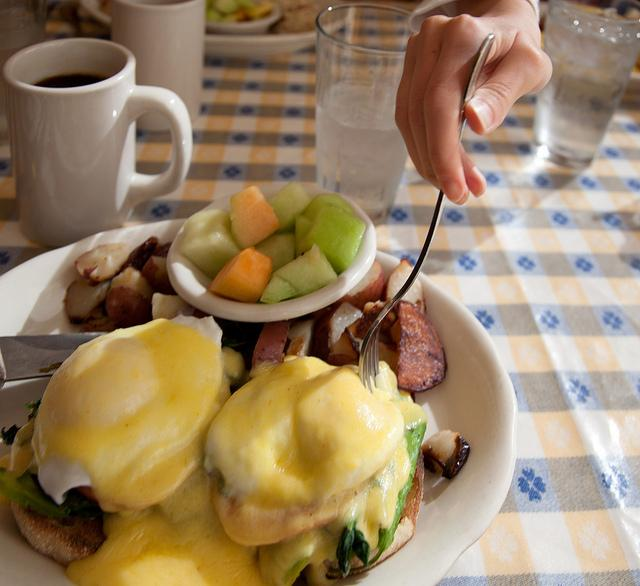What is in the small plate?

Choices:
A) chicken bone
B) cantaloupe
C) apple pie
D) cherry cantaloupe 